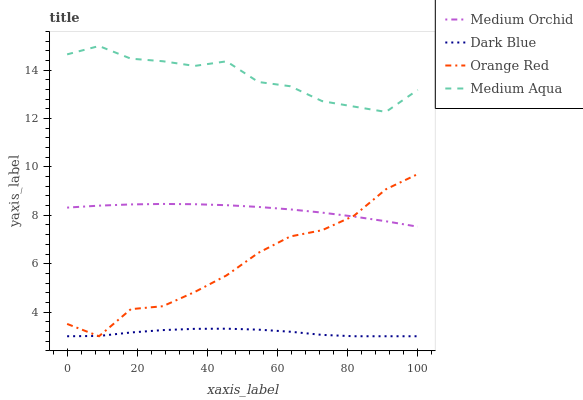Does Dark Blue have the minimum area under the curve?
Answer yes or no. Yes. Does Medium Aqua have the maximum area under the curve?
Answer yes or no. Yes. Does Medium Orchid have the minimum area under the curve?
Answer yes or no. No. Does Medium Orchid have the maximum area under the curve?
Answer yes or no. No. Is Medium Orchid the smoothest?
Answer yes or no. Yes. Is Medium Aqua the roughest?
Answer yes or no. Yes. Is Medium Aqua the smoothest?
Answer yes or no. No. Is Medium Orchid the roughest?
Answer yes or no. No. Does Dark Blue have the lowest value?
Answer yes or no. Yes. Does Medium Orchid have the lowest value?
Answer yes or no. No. Does Medium Aqua have the highest value?
Answer yes or no. Yes. Does Medium Orchid have the highest value?
Answer yes or no. No. Is Dark Blue less than Medium Aqua?
Answer yes or no. Yes. Is Medium Aqua greater than Medium Orchid?
Answer yes or no. Yes. Does Orange Red intersect Dark Blue?
Answer yes or no. Yes. Is Orange Red less than Dark Blue?
Answer yes or no. No. Is Orange Red greater than Dark Blue?
Answer yes or no. No. Does Dark Blue intersect Medium Aqua?
Answer yes or no. No. 